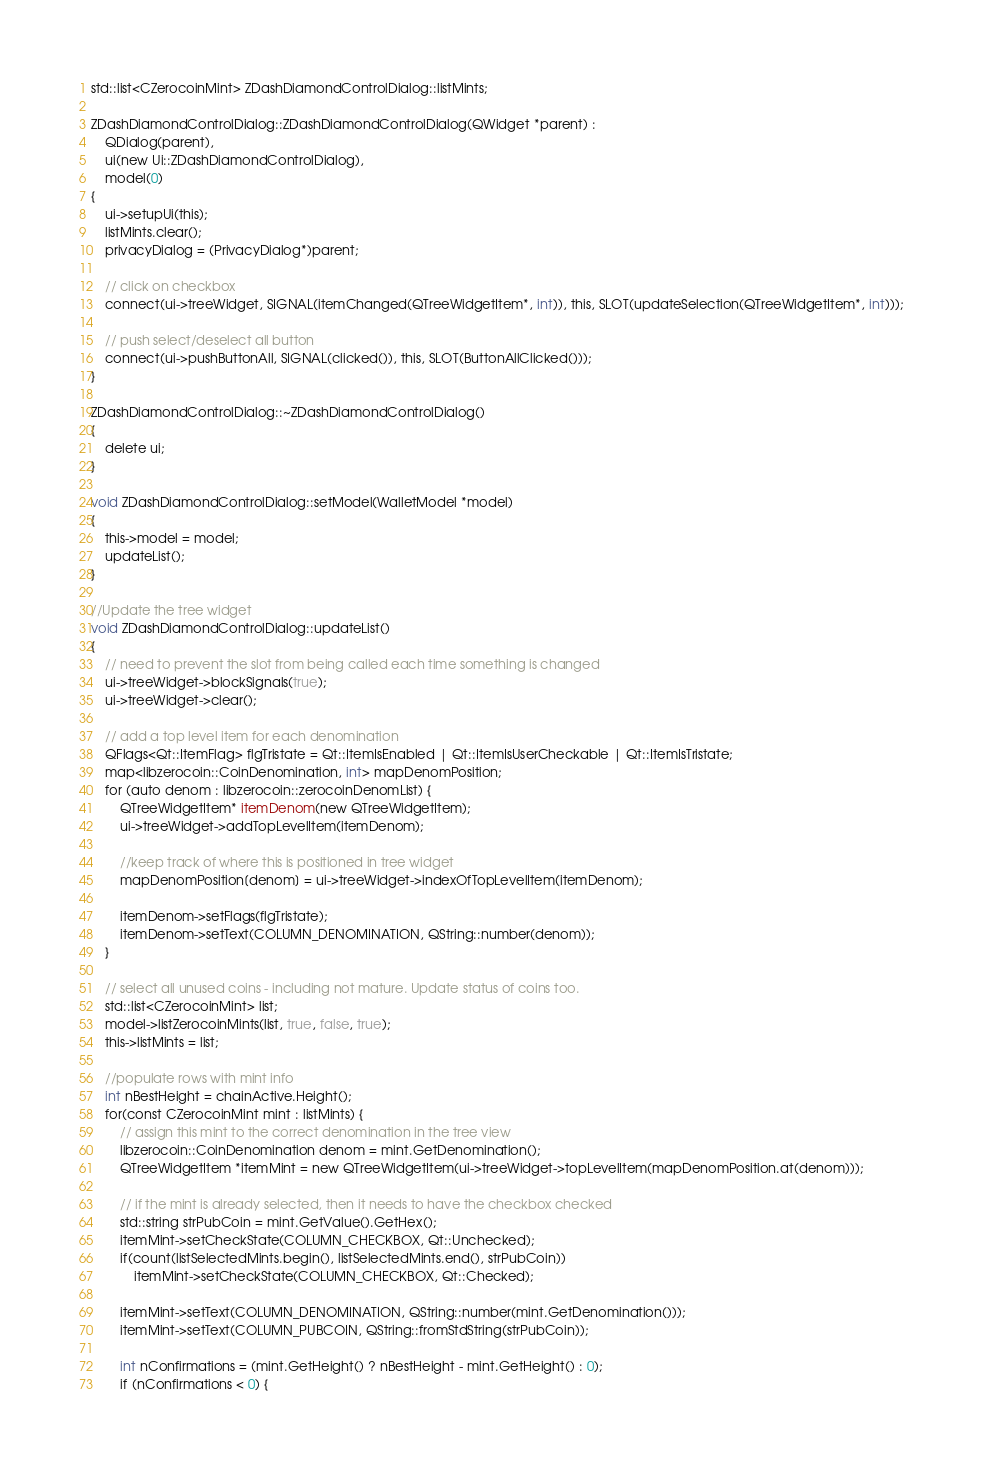Convert code to text. <code><loc_0><loc_0><loc_500><loc_500><_C++_>std::list<CZerocoinMint> ZDashDiamondControlDialog::listMints;

ZDashDiamondControlDialog::ZDashDiamondControlDialog(QWidget *parent) :
    QDialog(parent),
    ui(new Ui::ZDashDiamondControlDialog),
    model(0)
{
    ui->setupUi(this);
    listMints.clear();
    privacyDialog = (PrivacyDialog*)parent;

    // click on checkbox
    connect(ui->treeWidget, SIGNAL(itemChanged(QTreeWidgetItem*, int)), this, SLOT(updateSelection(QTreeWidgetItem*, int)));

    // push select/deselect all button
    connect(ui->pushButtonAll, SIGNAL(clicked()), this, SLOT(ButtonAllClicked()));
}

ZDashDiamondControlDialog::~ZDashDiamondControlDialog()
{
    delete ui;
}

void ZDashDiamondControlDialog::setModel(WalletModel *model)
{
    this->model = model;
    updateList();
}

//Update the tree widget
void ZDashDiamondControlDialog::updateList()
{
    // need to prevent the slot from being called each time something is changed
    ui->treeWidget->blockSignals(true);
    ui->treeWidget->clear();

    // add a top level item for each denomination
    QFlags<Qt::ItemFlag> flgTristate = Qt::ItemIsEnabled | Qt::ItemIsUserCheckable | Qt::ItemIsTristate;
    map<libzerocoin::CoinDenomination, int> mapDenomPosition;
    for (auto denom : libzerocoin::zerocoinDenomList) {
        QTreeWidgetItem* itemDenom(new QTreeWidgetItem);
        ui->treeWidget->addTopLevelItem(itemDenom);

        //keep track of where this is positioned in tree widget
        mapDenomPosition[denom] = ui->treeWidget->indexOfTopLevelItem(itemDenom);

        itemDenom->setFlags(flgTristate);
        itemDenom->setText(COLUMN_DENOMINATION, QString::number(denom));
    }

    // select all unused coins - including not mature. Update status of coins too.
    std::list<CZerocoinMint> list;
    model->listZerocoinMints(list, true, false, true);
    this->listMints = list;

    //populate rows with mint info
    int nBestHeight = chainActive.Height();
    for(const CZerocoinMint mint : listMints) {
        // assign this mint to the correct denomination in the tree view
        libzerocoin::CoinDenomination denom = mint.GetDenomination();
        QTreeWidgetItem *itemMint = new QTreeWidgetItem(ui->treeWidget->topLevelItem(mapDenomPosition.at(denom)));

        // if the mint is already selected, then it needs to have the checkbox checked
        std::string strPubCoin = mint.GetValue().GetHex();
        itemMint->setCheckState(COLUMN_CHECKBOX, Qt::Unchecked);
        if(count(listSelectedMints.begin(), listSelectedMints.end(), strPubCoin))
            itemMint->setCheckState(COLUMN_CHECKBOX, Qt::Checked);

        itemMint->setText(COLUMN_DENOMINATION, QString::number(mint.GetDenomination()));
        itemMint->setText(COLUMN_PUBCOIN, QString::fromStdString(strPubCoin));

        int nConfirmations = (mint.GetHeight() ? nBestHeight - mint.GetHeight() : 0);
        if (nConfirmations < 0) {</code> 